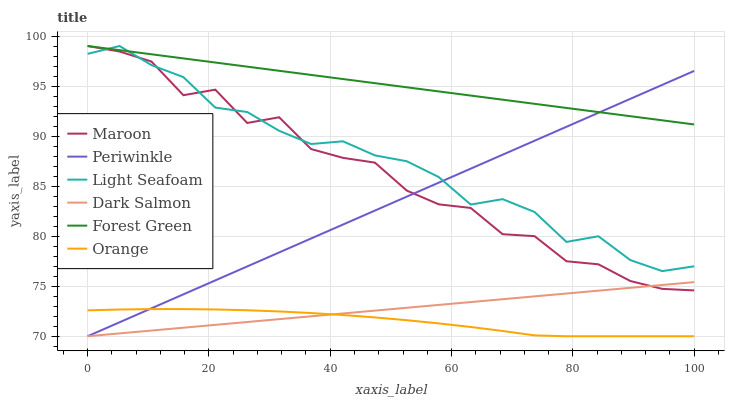Does Orange have the minimum area under the curve?
Answer yes or no. Yes. Does Forest Green have the maximum area under the curve?
Answer yes or no. Yes. Does Maroon have the minimum area under the curve?
Answer yes or no. No. Does Maroon have the maximum area under the curve?
Answer yes or no. No. Is Dark Salmon the smoothest?
Answer yes or no. Yes. Is Maroon the roughest?
Answer yes or no. Yes. Is Forest Green the smoothest?
Answer yes or no. No. Is Forest Green the roughest?
Answer yes or no. No. Does Maroon have the lowest value?
Answer yes or no. No. Does Light Seafoam have the highest value?
Answer yes or no. Yes. Does Periwinkle have the highest value?
Answer yes or no. No. Is Dark Salmon less than Light Seafoam?
Answer yes or no. Yes. Is Light Seafoam greater than Dark Salmon?
Answer yes or no. Yes. Does Periwinkle intersect Light Seafoam?
Answer yes or no. Yes. Is Periwinkle less than Light Seafoam?
Answer yes or no. No. Is Periwinkle greater than Light Seafoam?
Answer yes or no. No. Does Dark Salmon intersect Light Seafoam?
Answer yes or no. No. 